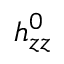<formula> <loc_0><loc_0><loc_500><loc_500>h _ { z z } ^ { 0 }</formula> 